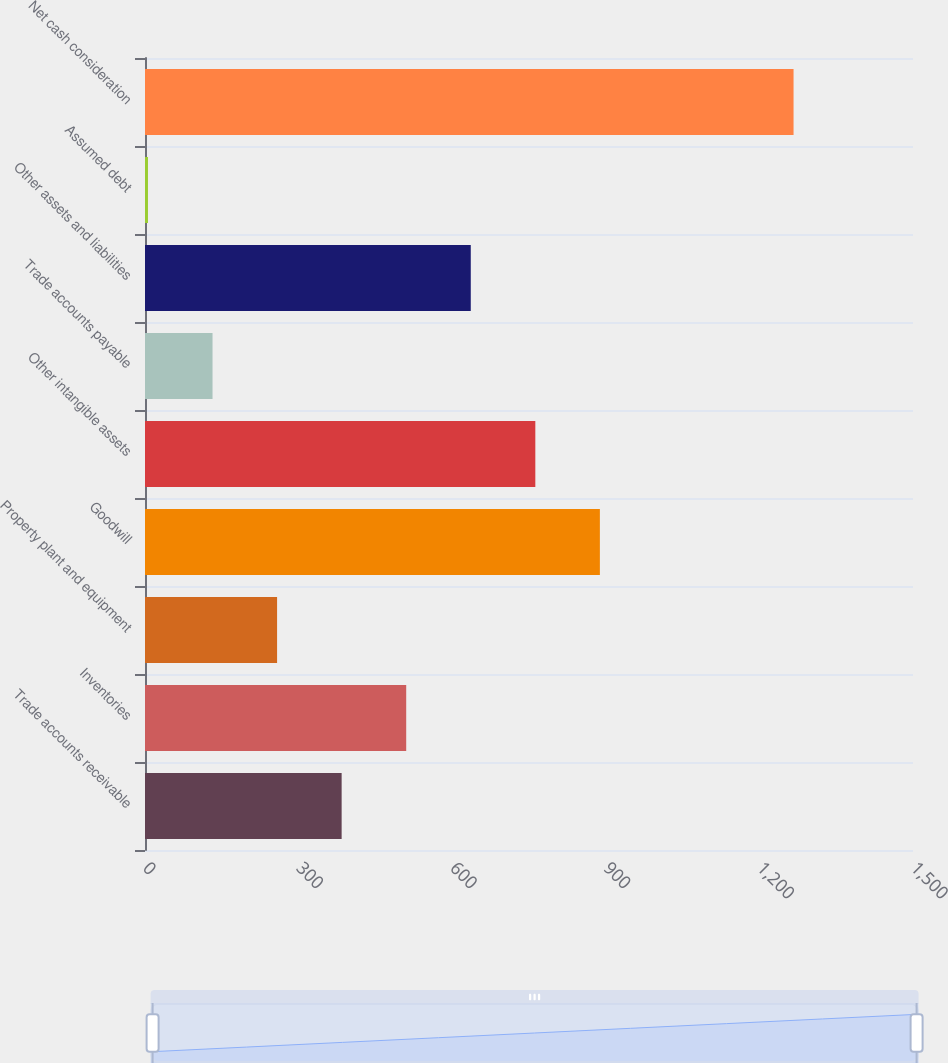Convert chart to OTSL. <chart><loc_0><loc_0><loc_500><loc_500><bar_chart><fcel>Trade accounts receivable<fcel>Inventories<fcel>Property plant and equipment<fcel>Goodwill<fcel>Other intangible assets<fcel>Trade accounts payable<fcel>Other assets and liabilities<fcel>Assumed debt<fcel>Net cash consideration<nl><fcel>384.07<fcel>510.16<fcel>257.98<fcel>888.43<fcel>762.34<fcel>131.89<fcel>636.25<fcel>5.8<fcel>1266.7<nl></chart> 